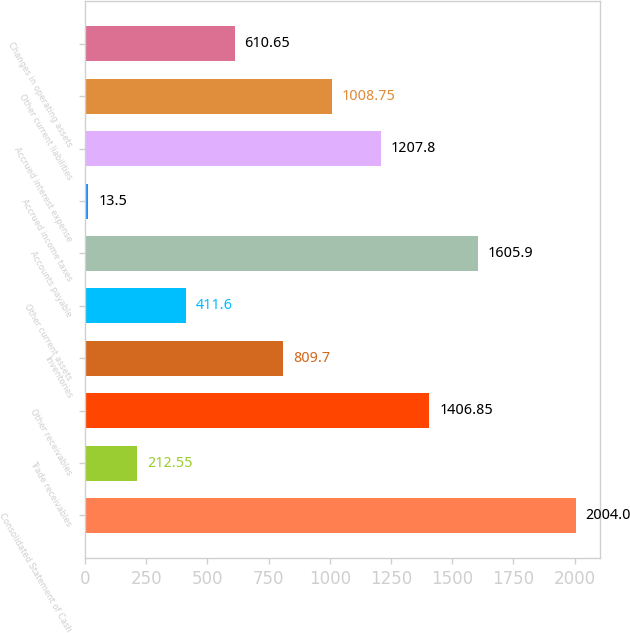<chart> <loc_0><loc_0><loc_500><loc_500><bar_chart><fcel>Consolidated Statement of Cash<fcel>Trade receivables<fcel>Other receivables<fcel>Inventories<fcel>Other current assets<fcel>Accounts payable<fcel>Accrued income taxes<fcel>Accrued interest expense<fcel>Other current liabilities<fcel>Changes in operating assets<nl><fcel>2004<fcel>212.55<fcel>1406.85<fcel>809.7<fcel>411.6<fcel>1605.9<fcel>13.5<fcel>1207.8<fcel>1008.75<fcel>610.65<nl></chart> 